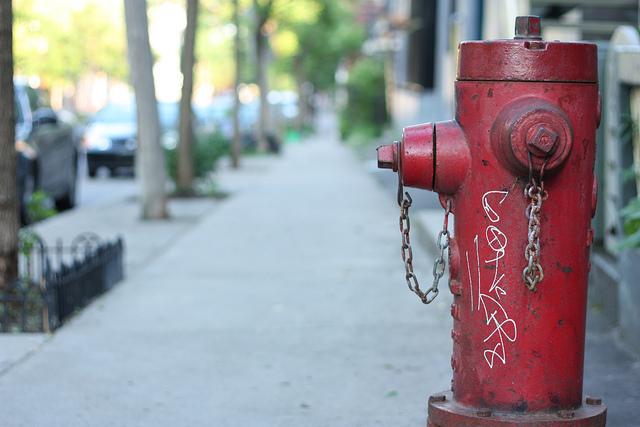Is there graffiti on the fire hydrant?
Give a very brief answer. Yes. What color is the hydrant?
Write a very short answer. Red. Is the hydrant prepared for use?
Write a very short answer. No. What colors are the fire hydrant?
Keep it brief. Red. Is there a mailbox on the sidewalk?
Short answer required. No. 